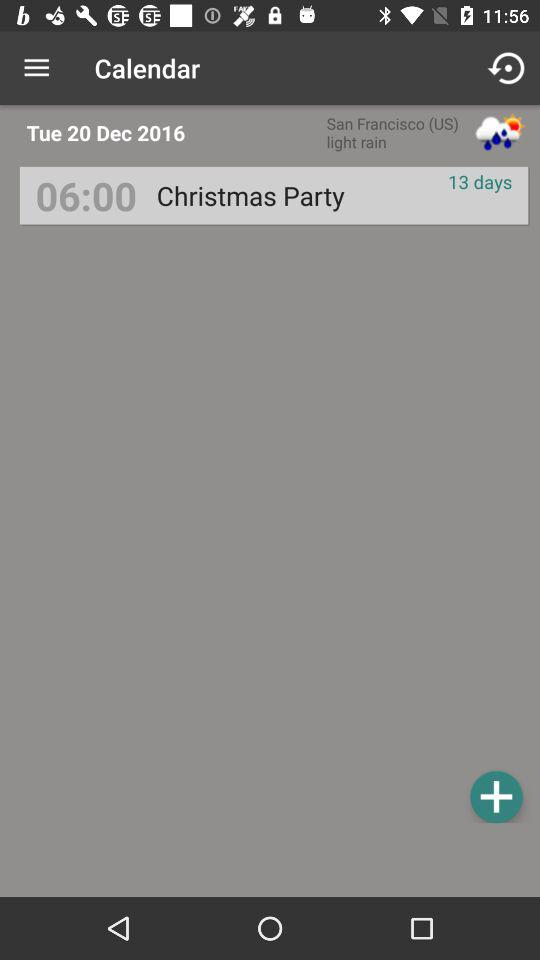What will be the weather in San Francisco(US) on the "20th of December 2016"? There will be light rain on December 20th, 2016. 